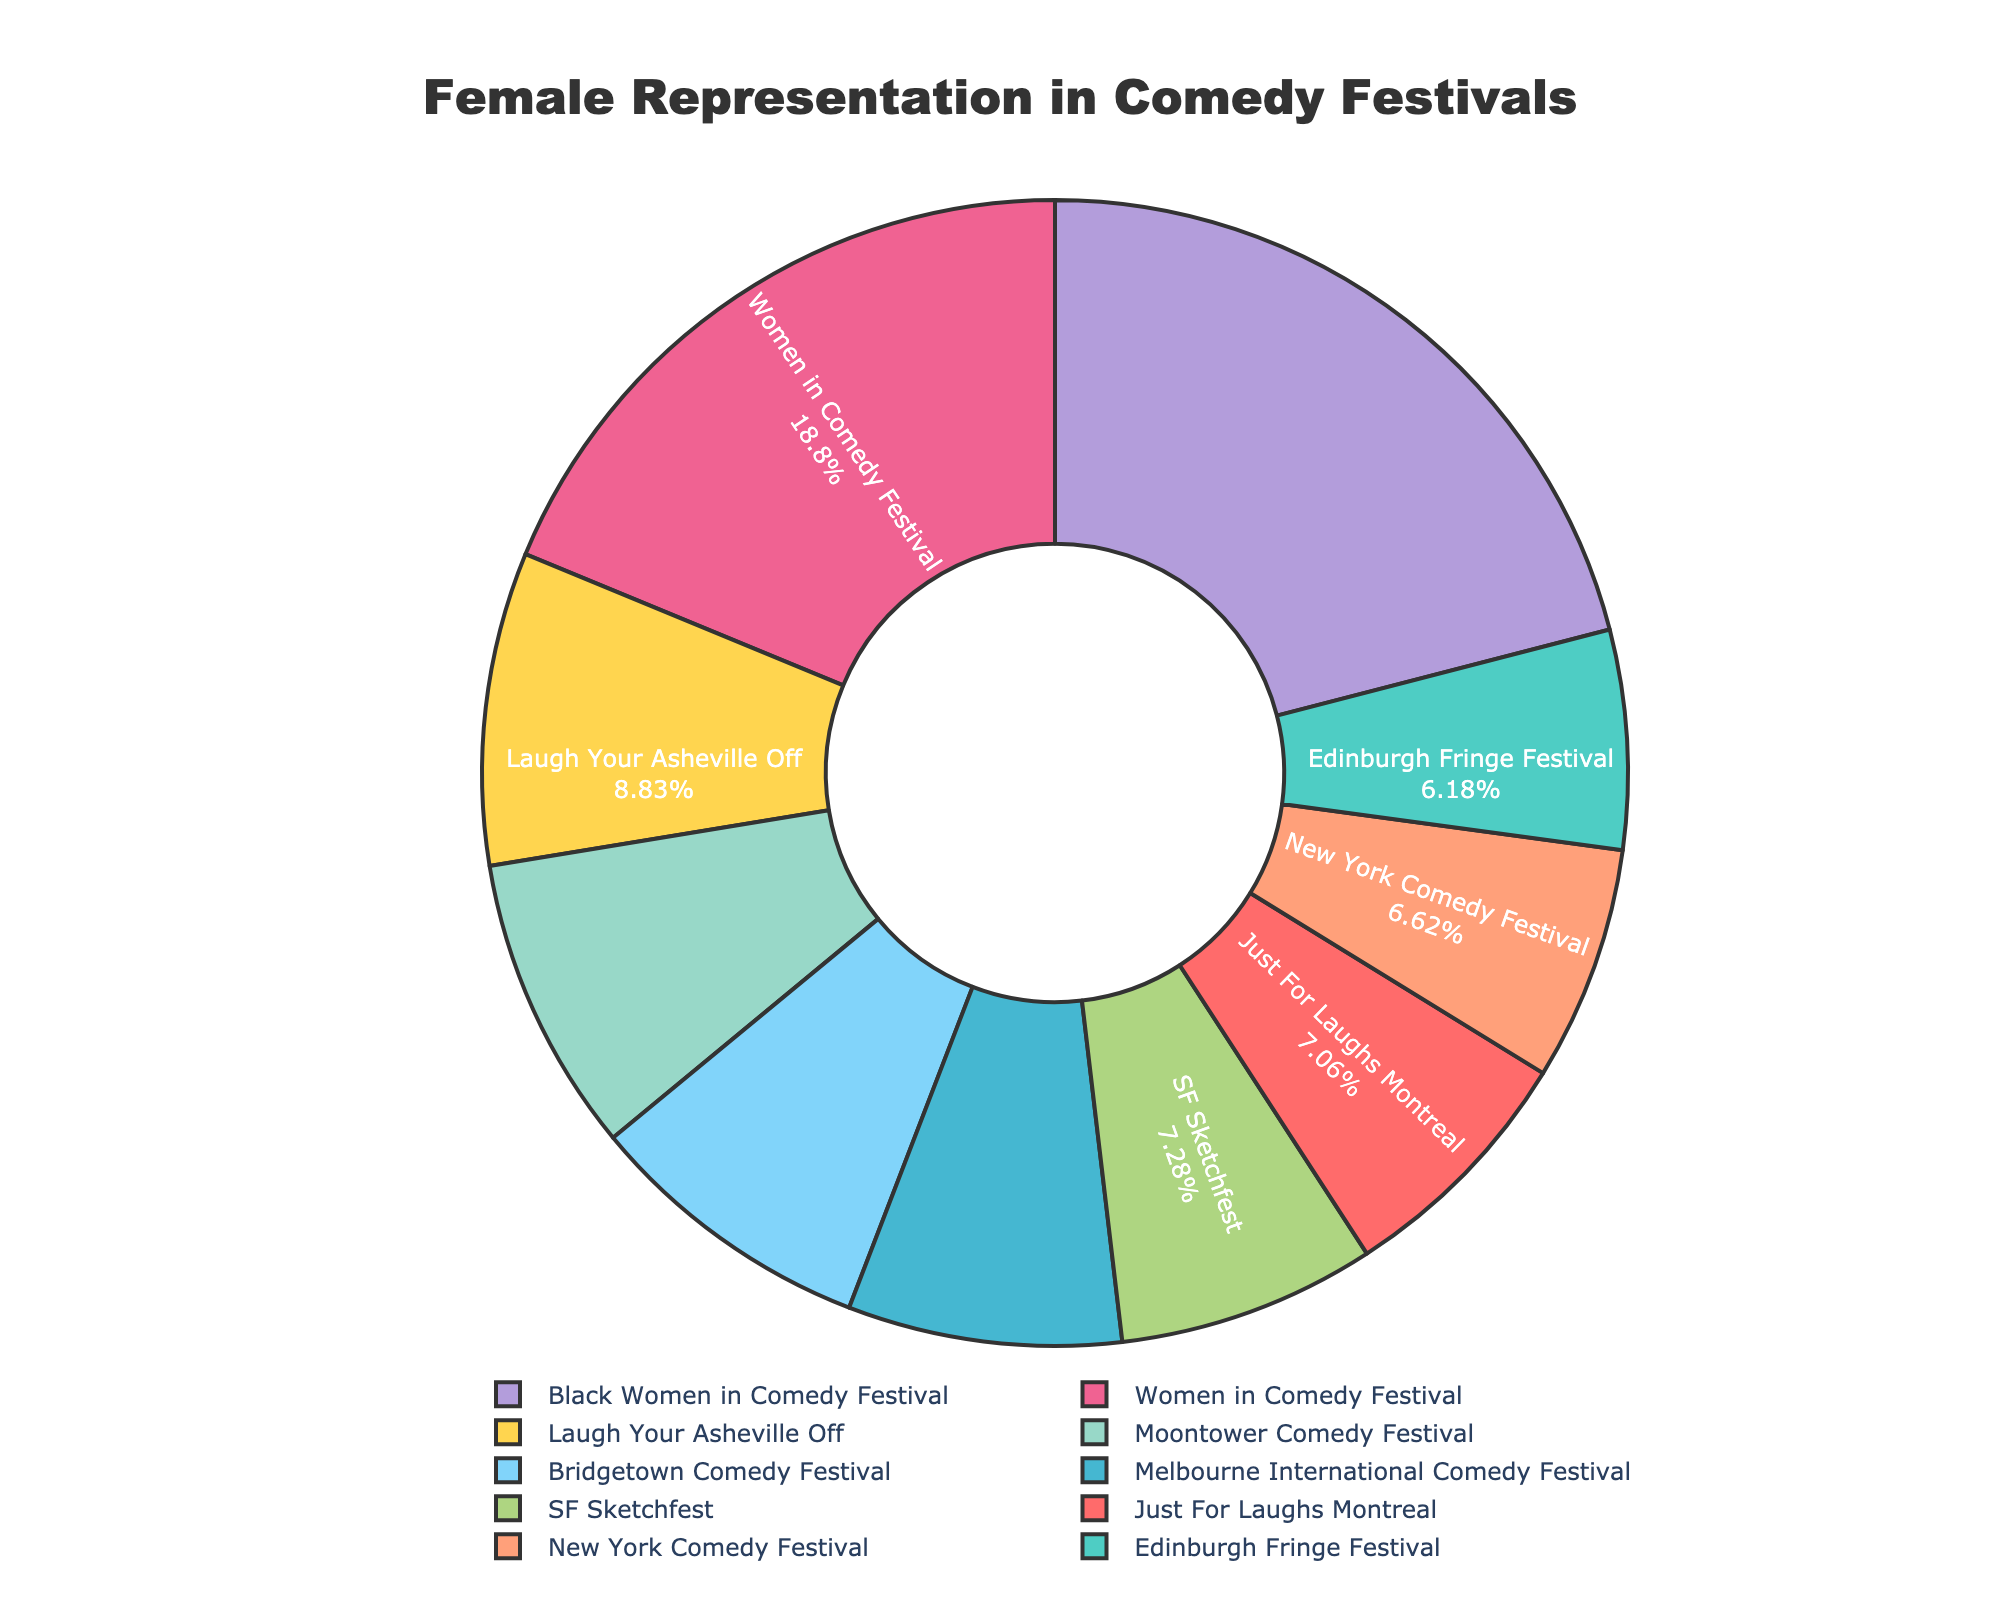What is the percentage of female comedians at the Black Women in Comedy Festival? Look at the segment labeled "Black Women in Comedy Festival" in the pie chart and read the percentage value given.
Answer: 95 Which comedy festival has the highest percentage of female comedians? Compare the percentage values for each festival and identify which is the highest. The Black Women in Comedy Festival has the highest percentage at 95%.
Answer: Black Women in Comedy Festival What is the difference in the percentage of female comedians between the Women in Comedy Festival and Just For Laughs Montreal? Subtract the percentage of Just For Laughs Montreal (32%) from the Women in Comedy Festival (85%). The difference is 85 - 32 = 53.
Answer: 53 How do the percentages of female comedians at the Moontower Comedy Festival and Edinburgh Fringe Festival compare? Identify the percentages for Moontower Comedy Festival (38%) and Edinburgh Fringe Festival (28%) and compare them. The Moontower Comedy Festival has a higher percentage.
Answer: Moontower Comedy Festival (38%) > Edinburgh Fringe Festival (28%) Which festival has a greater percentage of female comedians: SF Sketchfest or the Melbourne International Comedy Festival? Identify the percentages for SF Sketchfest (33%) and Melbourne International Comedy Festival (35%) and compare them. The Melbourne International Comedy Festival has a greater percentage.
Answer: Melbourne International Comedy Festival What is the average percentage of female comedians across all festivals? Add up all the percentages and divide by the number of festivals. (32 + 28 + 35 + 30 + 38 + 85 + 33 + 40 + 37 + 95) / 10 = 45.3
Answer: 45.3 Which festival has the closest percentage of female comedians to the New York Comedy Festival? Identify the percentage for the New York Comedy Festival (30%) and compare it with all other festivals: Just For Laughs Montreal (32%) is the closest.
Answer: Just For Laughs Montreal How much higher is the percentage of female comedians at the Bridgetown Comedy Festival compared to the SF Sketchfest? Subtract the percentage of SF Sketchfest (33%) from Bridgetown Comedy Festival (37%). The difference is 37 - 33 = 4.
Answer: 4 What is the color used for the segment representing the Laugh Your Asheville Off festival? Observe the pie chart and identify the color corresponding to the "Laugh Your Asheville Off" segment.
Answer: Yellow Which festival has the lowest percentage of female comedians, and what is that percentage? Identify and compare all percentages. The Edinburgh Fringe Festival has the lowest percentage, which is 28%.
Answer: Edinburgh Fringe Festival, 28% 